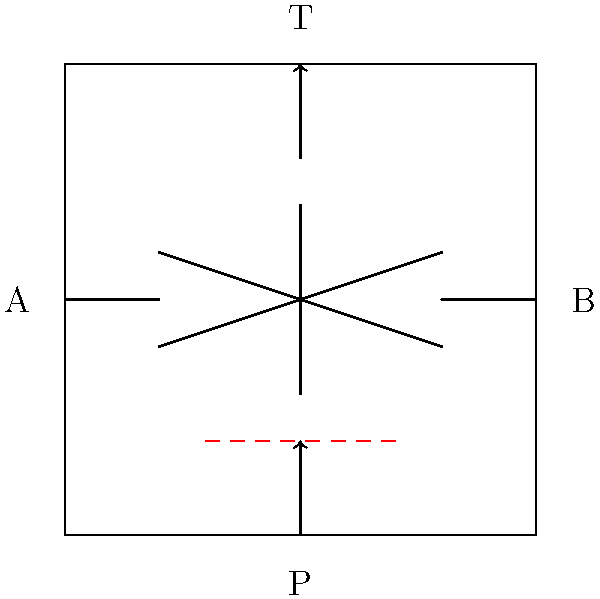In the given hydraulic circuit diagram for a basic control valve, there is an error that would prevent proper functioning. Identify the issue and explain how to resolve it to ensure correct operation of the hydraulic system. To identify and resolve the issue in this hydraulic circuit diagram, follow these steps:

1. Analyze the circuit components:
   - The diagram shows a basic 4-way, 3-position control valve.
   - Port P is the pressure inlet.
   - Port T is the tank (return) line.
   - Ports A and B are work ports connected to actuators.

2. Identify the error:
   - There is a dashed red line connecting the P and T ports directly.
   - This represents an incorrect bypass or short circuit between pressure and tank.

3. Understand the problem:
   - A direct connection between P and T would allow hydraulic fluid to flow freely from the pressure source back to the tank.
   - This would result in a loss of pressure in the system, preventing proper operation of actuators.

4. Resolve the issue:
   - Remove the bypass line between P and T.
   - Ensure that the only connections between P and T are through the control valve.

5. Correct operation:
   - With the bypass removed, the control valve can properly direct flow:
     a) In the neutral position, all ports are blocked.
     b) In one active position, P connects to A, and B connects to T.
     c) In the other active position, P connects to B, and A connects to T.

6. Importance for graduates:
   - Understanding basic hydraulic circuits is crucial for mechanical engineers.
   - The ability to identify and resolve such issues demonstrates practical knowledge and troubleshooting skills.

By addressing this error, the hydraulic system will function as intended, allowing proper control of actuators and maintaining system pressure.
Answer: Remove the bypass line between pressure (P) and tank (T) ports. 